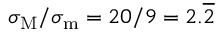Convert formula to latex. <formula><loc_0><loc_0><loc_500><loc_500>\sigma _ { M } / \sigma _ { m } = 2 0 / 9 = 2 . \overline { 2 }</formula> 